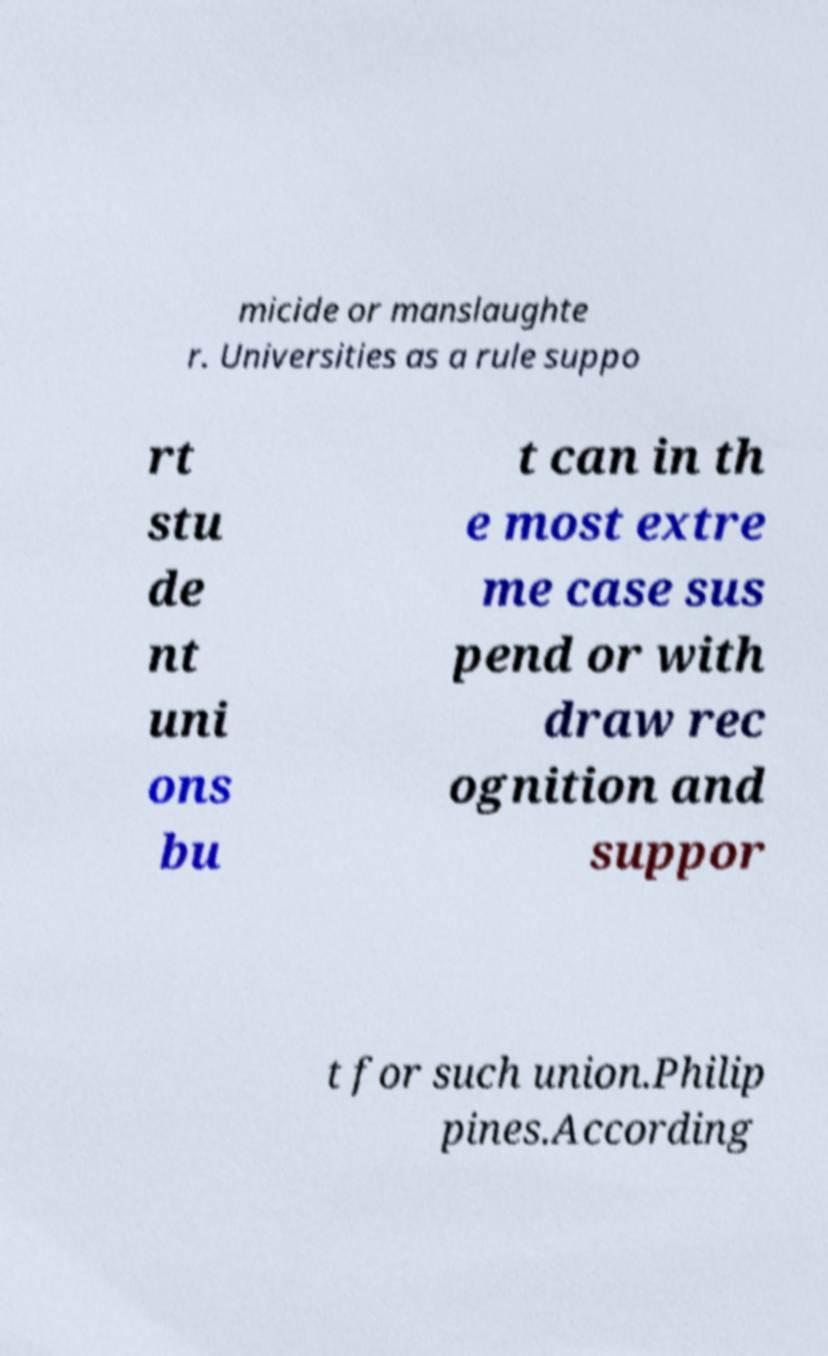I need the written content from this picture converted into text. Can you do that? micide or manslaughte r. Universities as a rule suppo rt stu de nt uni ons bu t can in th e most extre me case sus pend or with draw rec ognition and suppor t for such union.Philip pines.According 